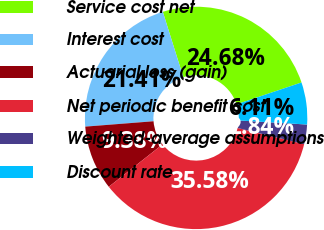<chart> <loc_0><loc_0><loc_500><loc_500><pie_chart><fcel>Service cost net<fcel>Interest cost<fcel>Actuarial loss (gain)<fcel>Net periodic benefit cost<fcel>Weighted-average assumptions<fcel>Discount rate<nl><fcel>24.68%<fcel>21.41%<fcel>9.38%<fcel>35.58%<fcel>2.84%<fcel>6.11%<nl></chart> 